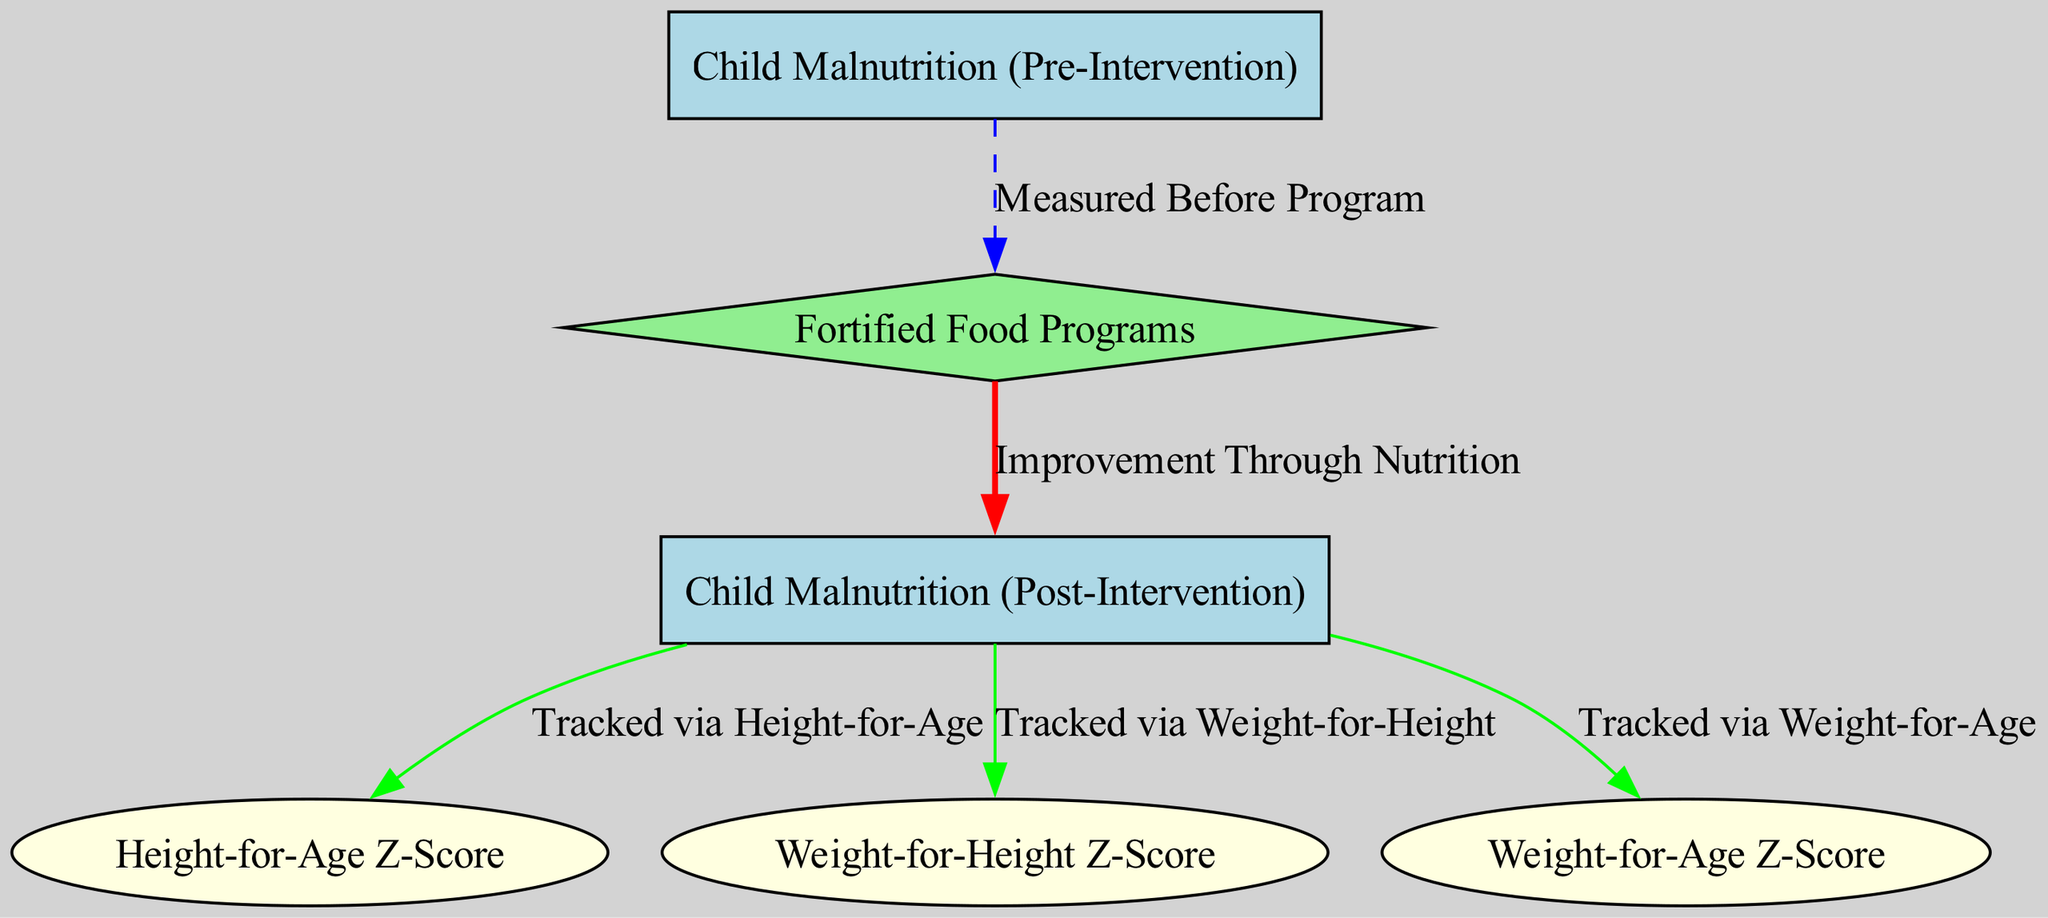What is the intervention introduced in this diagram? The diagram indicates that the intervention is "Fortified Food Programs." This is labeled as an intervention node in the diagram, depicted in diamond shape with a light green color.
Answer: Fortified Food Programs How many metrics are tracked after the intervention? The diagram shows three metric-correlation edges leading away from the "Child Malnutrition (Post-Intervention)" node. These metrics are "Height-for-Age Z-Score," "Weight-for-Height Z-Score," and "Weight-for-Age Z-Score." Thus, there are three metrics tracked.
Answer: 3 What relationship is shown between "Fortified Food Programs" and "Child Malnutrition (Post-Intervention)"? The diagram indicates a causative relationship represented by a red bold edge labeled "Improvement Through Nutrition." This signifies that the introduction of fortified food programs is intended to improve child malnutrition outcomes.
Answer: Improvement Through Nutrition What measurement was taken before the program? The diagram states that "Child Malnutrition (Pre-Intervention)" is measured before the program is introduced. There is a blue dashed edge labeled "Measured Before Program" connecting this metric to the fortified food programs.
Answer: Child Malnutrition (Pre-Intervention) Which metric correlates with "Child Malnutrition (Post-Intervention)" regarding children's growth? The diagram links several metrics to "Child Malnutrition (Post-Intervention)." It specifically indicates that "Height-for-Age Z-Score," "Weight-for-Height Z-Score," and "Weight-for-Age Z-Score" are correlated metrics. Out of these, any can be considered as a correlation, but "Height-for-Age Z-Score" is commonly used to assess growth in children directly.
Answer: Height-for-Age Z-Score What type of edges are used to represent metrics in the diagram? The diagram utilizes green edges to represent metric correlations. This coloring indicates that there is a metric-correlation relationship between "Child Malnutrition (Post-Intervention)" and the associated metrics.
Answer: Metric-correlation What is the color and shape of nodes indicating interventions in the diagram? The intervention nodes in the diagram, specifically "Fortified Food Programs," are represented as diamond shapes colored light green. This distinct shape and color help to categorize the intervention aspect of the diagram.
Answer: Diamond shape, light green What does the edge label "Tracked via Height-for-Age" signify? This edge label indicates that the "Height-for-Age Z-Score" is a metric that is monitored and measured in relation to the outcomes of "Child Malnutrition (Post-Intervention)." It signifies a correlation where changes in malnutrition status can be assessed via height-for-age measurements.
Answer: Tracked via Height-for-Age 